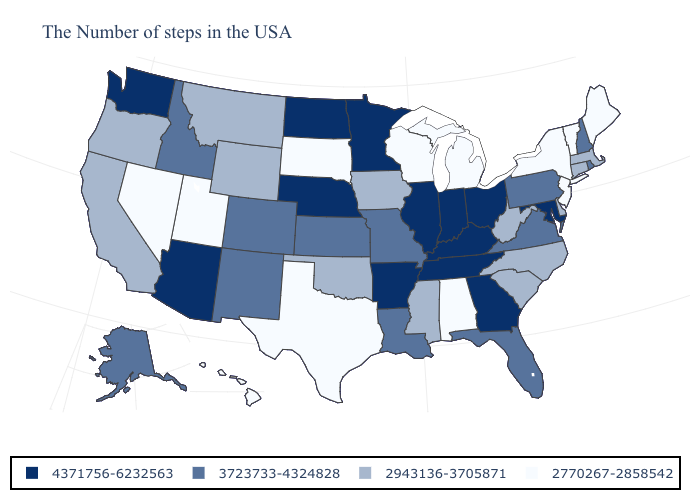What is the value of Washington?
Quick response, please. 4371756-6232563. What is the value of Vermont?
Short answer required. 2770267-2858542. Does Kansas have the lowest value in the USA?
Concise answer only. No. Which states have the lowest value in the Northeast?
Be succinct. Maine, Vermont, New York, New Jersey. Name the states that have a value in the range 3723733-4324828?
Keep it brief. Rhode Island, New Hampshire, Pennsylvania, Virginia, Florida, Louisiana, Missouri, Kansas, Colorado, New Mexico, Idaho, Alaska. What is the highest value in states that border Vermont?
Be succinct. 3723733-4324828. How many symbols are there in the legend?
Quick response, please. 4. How many symbols are there in the legend?
Give a very brief answer. 4. What is the lowest value in states that border Tennessee?
Write a very short answer. 2770267-2858542. Name the states that have a value in the range 2770267-2858542?
Give a very brief answer. Maine, Vermont, New York, New Jersey, Michigan, Alabama, Wisconsin, Texas, South Dakota, Utah, Nevada, Hawaii. What is the lowest value in the USA?
Quick response, please. 2770267-2858542. Name the states that have a value in the range 2770267-2858542?
Answer briefly. Maine, Vermont, New York, New Jersey, Michigan, Alabama, Wisconsin, Texas, South Dakota, Utah, Nevada, Hawaii. Does New Mexico have the highest value in the USA?
Concise answer only. No. Does the first symbol in the legend represent the smallest category?
Short answer required. No. Name the states that have a value in the range 2770267-2858542?
Give a very brief answer. Maine, Vermont, New York, New Jersey, Michigan, Alabama, Wisconsin, Texas, South Dakota, Utah, Nevada, Hawaii. 